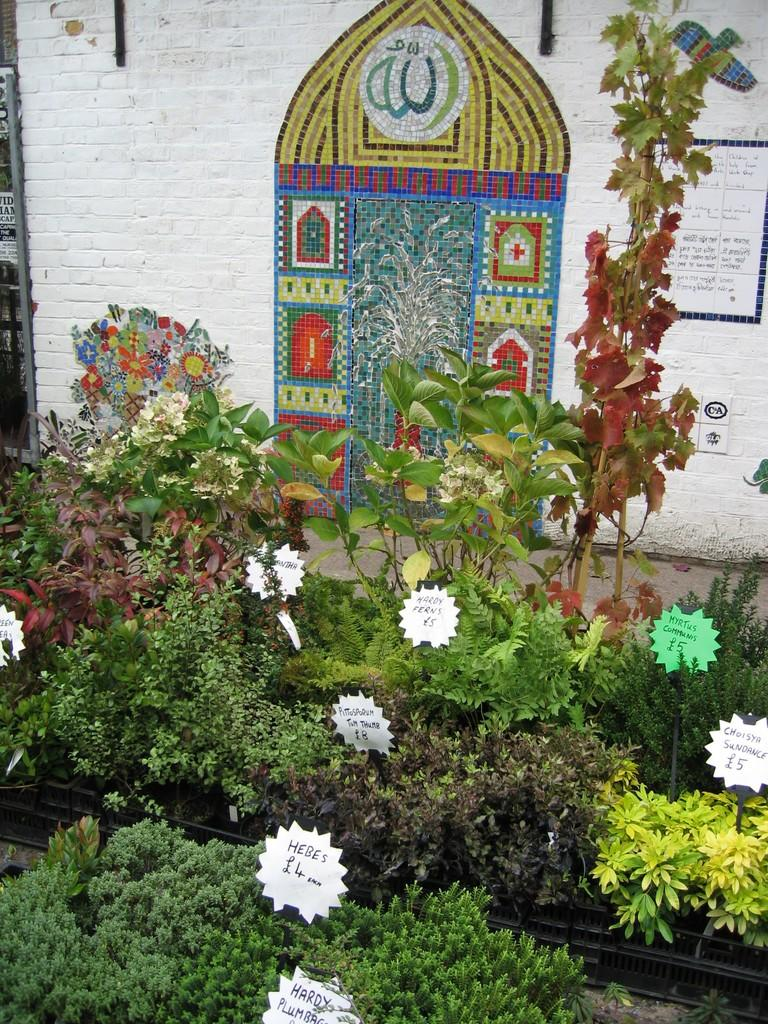What is located at the bottom of the image? There are plants at the bottom of the image. What is placed on the plants? There are papers on the plants. What is visible at the top of the image? There is a wall at the top of the image. What is featured on the wall? There is a painting on the wall and a paper attached to the wall. How does the painting on the wall spark a conversation with the viewers? The image does not provide information about the painting sparking a conversation with viewers, nor does it mention any spark. 